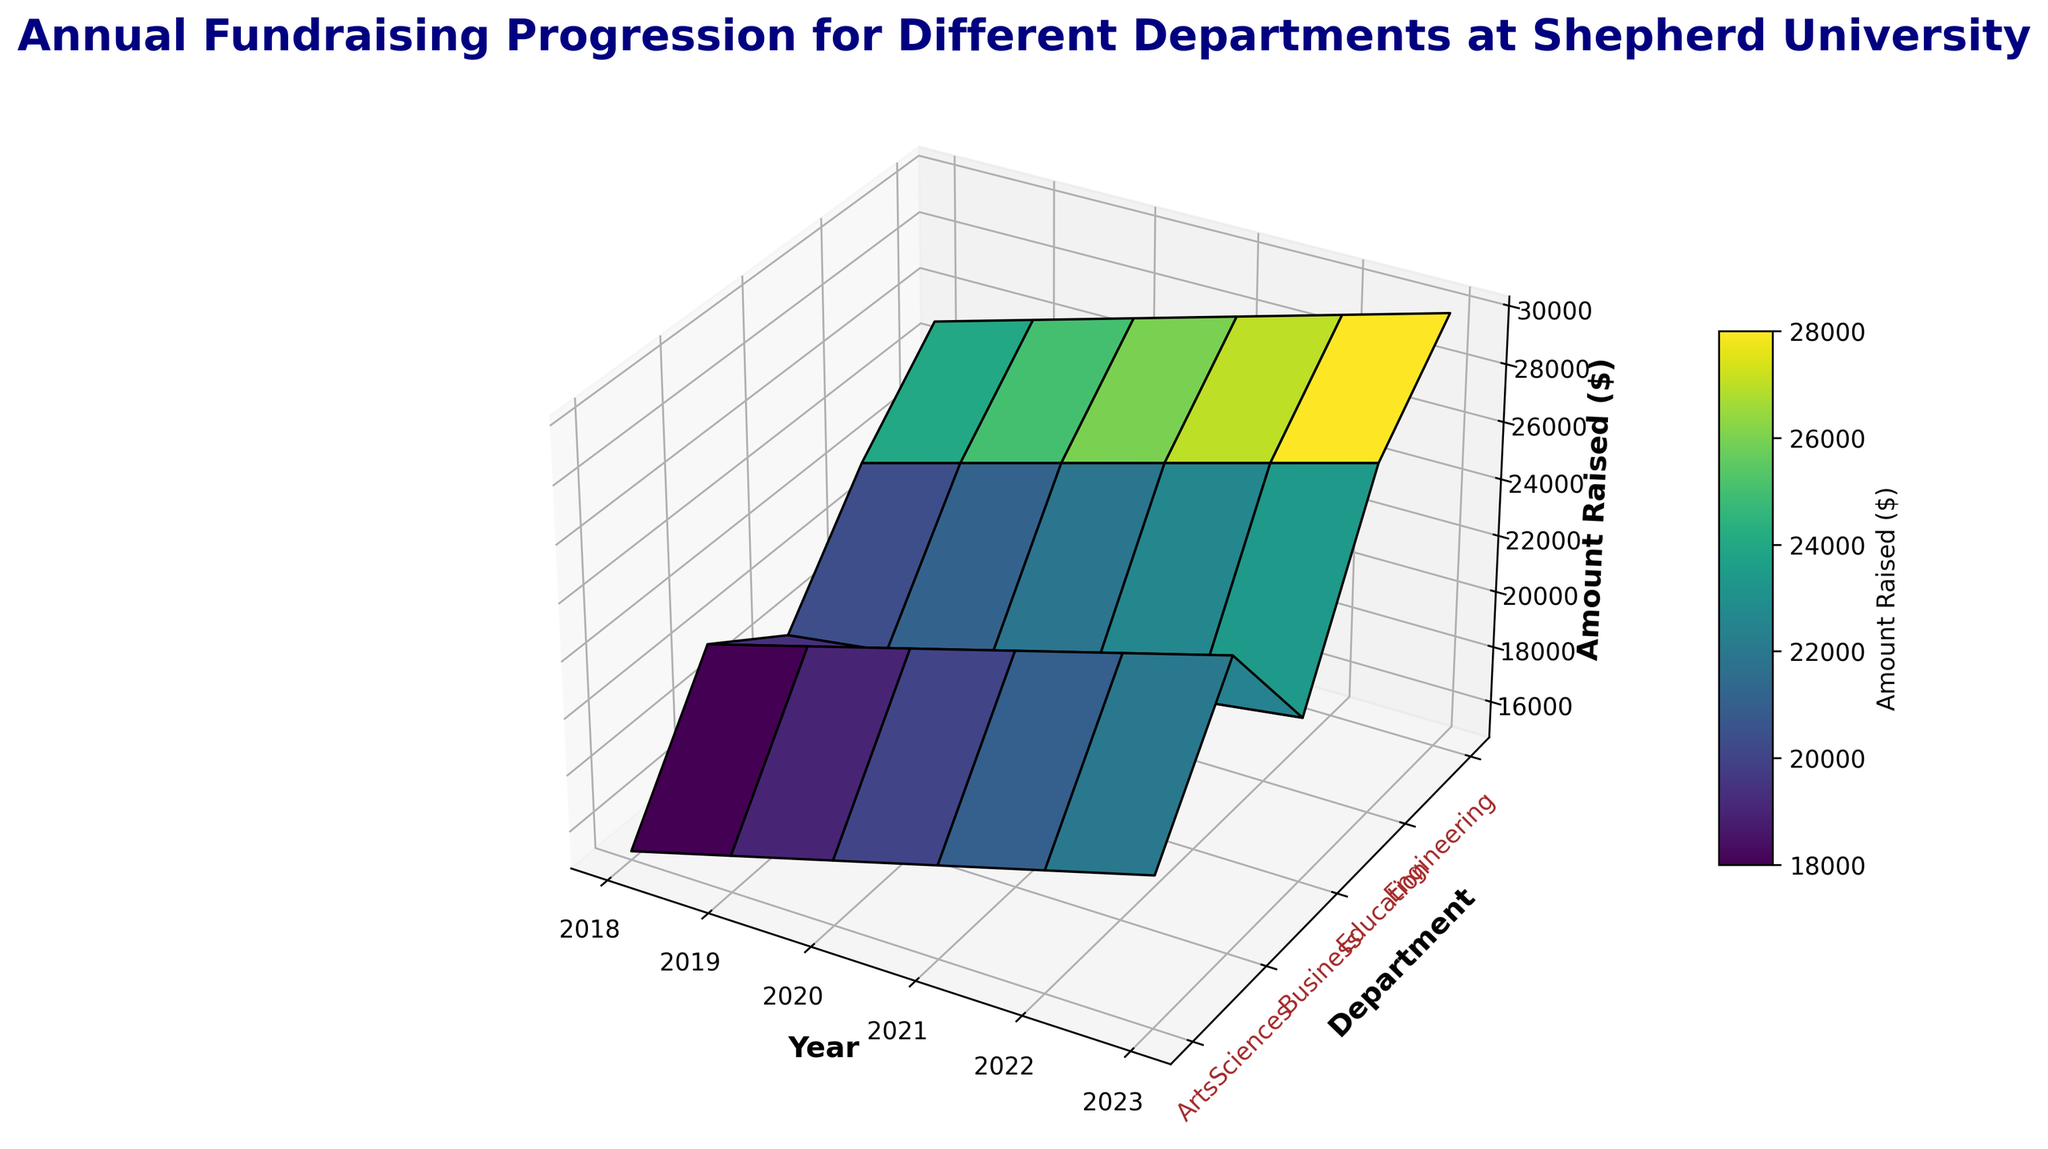Which department had the highest amount raised in 2023? To find the department with the highest amount raised in 2023, locate the 2023 column on the surface plot and identify the highest peak. The department with the peak amount is Engineering.
Answer: Engineering What is the average amount raised by the Arts department from 2018 to 2023? To calculate the average, sum the amounts raised from 2018 to 2023 for the Arts department (15000, 16000, 17000, 18000, 19000, 20000), which totals 105000, and then divide by the number of years (6). The average is 105000 / 6 = 17500.
Answer: 17500 Which year showed the largest increase in fundraising for the Business department? To determine which year had the largest increase, compare the amount raised between consecutive years for the Business department. The differences are: 2018 to 2019 (500), 2019 to 2020 (500), 2020 to 2021 (500), 2021 to 2022 (500), 2022 to 2023 (500). Each year has the same increase of 500, so it's consistent rather than a single year showing a larger increase.
Answer: Consistent Increase How much more did the Engineering department raise compared to the Arts department in 2020? Locate the amounts for both Engineering and Arts in 2020. Engineering raised 27000, and Arts raised 17000. Subtract the Arts' amount from Engineering's: 27000 - 17000 = 10000.
Answer: 10000 Which department had the steepest growth in fundraising from 2018 to 2023? To find the steepest growth, calculate the difference in fundraising amounts from 2018 to 2023 for each department. Engineering increased by (30000 - 25000 = 5000), Education by (27000 - 22000 = 5000), Business by (20500 - 18000 = 2500), Sciences by (25000 - 20000 = 5000), Arts by (20000 - 15000 = 5000). Engineering, Education, and Sciences show the same steepest growth of 5000.
Answer: Engineering, Education, Sciences What was the total amount raised by all departments in 2019? Sum the amounts raised by Arts (16000), Sciences (21000), Business (18500), Education (23000), and Engineering (26000) in 2019. The total is 16000 + 21000 + 18500 + 23000 + 26000 = 104500.
Answer: 104500 